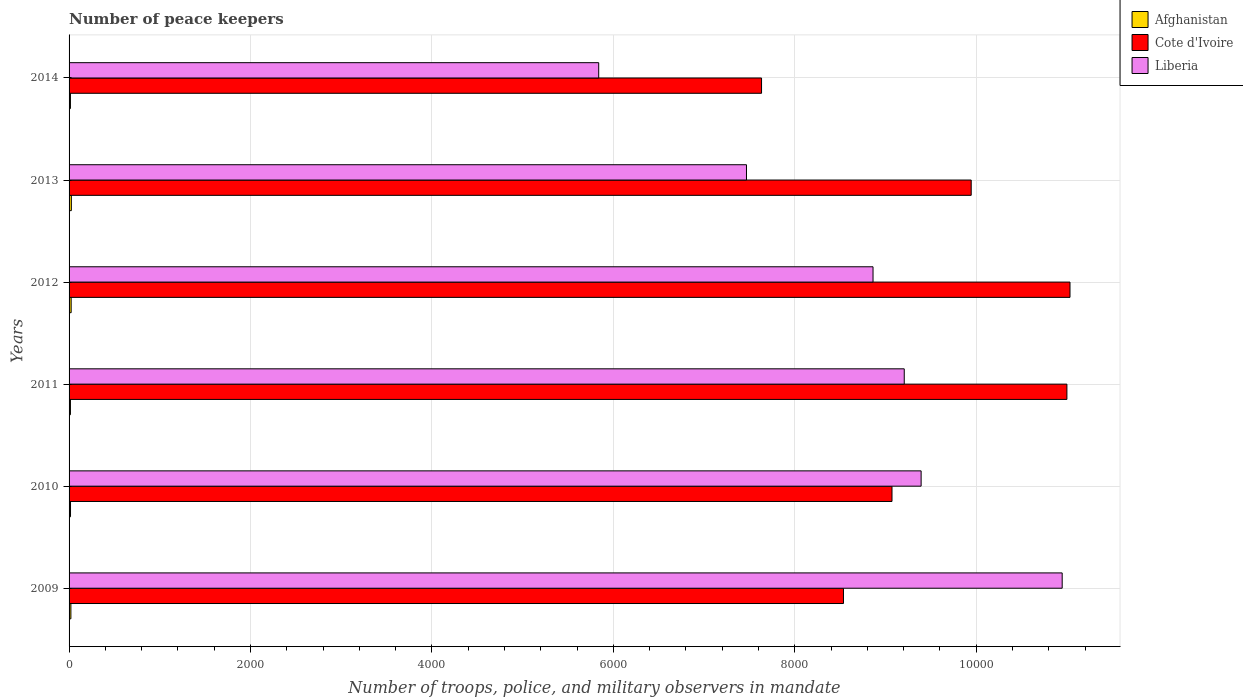How many different coloured bars are there?
Offer a terse response. 3. What is the label of the 1st group of bars from the top?
Keep it short and to the point. 2014. Across all years, what is the minimum number of peace keepers in in Afghanistan?
Make the answer very short. 15. What is the total number of peace keepers in in Afghanistan in the graph?
Keep it short and to the point. 114. What is the difference between the number of peace keepers in in Afghanistan in 2011 and the number of peace keepers in in Liberia in 2014?
Provide a succinct answer. -5823. What is the average number of peace keepers in in Afghanistan per year?
Your answer should be compact. 19. In the year 2013, what is the difference between the number of peace keepers in in Liberia and number of peace keepers in in Afghanistan?
Make the answer very short. 7442. In how many years, is the number of peace keepers in in Liberia greater than 8400 ?
Your answer should be compact. 4. What is the ratio of the number of peace keepers in in Afghanistan in 2011 to that in 2012?
Provide a short and direct response. 0.65. Is the difference between the number of peace keepers in in Liberia in 2010 and 2013 greater than the difference between the number of peace keepers in in Afghanistan in 2010 and 2013?
Provide a succinct answer. Yes. What is the difference between the highest and the second highest number of peace keepers in in Cote d'Ivoire?
Your answer should be very brief. 34. What is the difference between the highest and the lowest number of peace keepers in in Liberia?
Ensure brevity in your answer.  5109. In how many years, is the number of peace keepers in in Liberia greater than the average number of peace keepers in in Liberia taken over all years?
Your answer should be compact. 4. Is the sum of the number of peace keepers in in Cote d'Ivoire in 2010 and 2011 greater than the maximum number of peace keepers in in Afghanistan across all years?
Provide a succinct answer. Yes. What does the 3rd bar from the top in 2009 represents?
Make the answer very short. Afghanistan. What does the 1st bar from the bottom in 2011 represents?
Provide a short and direct response. Afghanistan. Is it the case that in every year, the sum of the number of peace keepers in in Cote d'Ivoire and number of peace keepers in in Liberia is greater than the number of peace keepers in in Afghanistan?
Keep it short and to the point. Yes. Are all the bars in the graph horizontal?
Your answer should be compact. Yes. How many years are there in the graph?
Provide a short and direct response. 6. Are the values on the major ticks of X-axis written in scientific E-notation?
Make the answer very short. No. How many legend labels are there?
Provide a short and direct response. 3. How are the legend labels stacked?
Offer a terse response. Vertical. What is the title of the graph?
Your response must be concise. Number of peace keepers. Does "Mozambique" appear as one of the legend labels in the graph?
Offer a terse response. No. What is the label or title of the X-axis?
Your response must be concise. Number of troops, police, and military observers in mandate. What is the label or title of the Y-axis?
Your answer should be compact. Years. What is the Number of troops, police, and military observers in mandate of Cote d'Ivoire in 2009?
Offer a terse response. 8536. What is the Number of troops, police, and military observers in mandate in Liberia in 2009?
Ensure brevity in your answer.  1.09e+04. What is the Number of troops, police, and military observers in mandate of Afghanistan in 2010?
Offer a terse response. 16. What is the Number of troops, police, and military observers in mandate in Cote d'Ivoire in 2010?
Make the answer very short. 9071. What is the Number of troops, police, and military observers in mandate in Liberia in 2010?
Ensure brevity in your answer.  9392. What is the Number of troops, police, and military observers in mandate in Afghanistan in 2011?
Keep it short and to the point. 15. What is the Number of troops, police, and military observers in mandate in Cote d'Ivoire in 2011?
Offer a very short reply. 1.10e+04. What is the Number of troops, police, and military observers in mandate of Liberia in 2011?
Your answer should be compact. 9206. What is the Number of troops, police, and military observers in mandate in Afghanistan in 2012?
Ensure brevity in your answer.  23. What is the Number of troops, police, and military observers in mandate of Cote d'Ivoire in 2012?
Keep it short and to the point. 1.10e+04. What is the Number of troops, police, and military observers in mandate of Liberia in 2012?
Your response must be concise. 8862. What is the Number of troops, police, and military observers in mandate in Cote d'Ivoire in 2013?
Ensure brevity in your answer.  9944. What is the Number of troops, police, and military observers in mandate in Liberia in 2013?
Give a very brief answer. 7467. What is the Number of troops, police, and military observers in mandate of Afghanistan in 2014?
Offer a terse response. 15. What is the Number of troops, police, and military observers in mandate of Cote d'Ivoire in 2014?
Provide a succinct answer. 7633. What is the Number of troops, police, and military observers in mandate of Liberia in 2014?
Your response must be concise. 5838. Across all years, what is the maximum Number of troops, police, and military observers in mandate of Afghanistan?
Give a very brief answer. 25. Across all years, what is the maximum Number of troops, police, and military observers in mandate in Cote d'Ivoire?
Offer a terse response. 1.10e+04. Across all years, what is the maximum Number of troops, police, and military observers in mandate of Liberia?
Ensure brevity in your answer.  1.09e+04. Across all years, what is the minimum Number of troops, police, and military observers in mandate of Afghanistan?
Make the answer very short. 15. Across all years, what is the minimum Number of troops, police, and military observers in mandate in Cote d'Ivoire?
Keep it short and to the point. 7633. Across all years, what is the minimum Number of troops, police, and military observers in mandate of Liberia?
Give a very brief answer. 5838. What is the total Number of troops, police, and military observers in mandate in Afghanistan in the graph?
Make the answer very short. 114. What is the total Number of troops, police, and military observers in mandate of Cote d'Ivoire in the graph?
Your answer should be very brief. 5.72e+04. What is the total Number of troops, police, and military observers in mandate of Liberia in the graph?
Provide a succinct answer. 5.17e+04. What is the difference between the Number of troops, police, and military observers in mandate in Afghanistan in 2009 and that in 2010?
Provide a short and direct response. 4. What is the difference between the Number of troops, police, and military observers in mandate in Cote d'Ivoire in 2009 and that in 2010?
Offer a terse response. -535. What is the difference between the Number of troops, police, and military observers in mandate in Liberia in 2009 and that in 2010?
Keep it short and to the point. 1555. What is the difference between the Number of troops, police, and military observers in mandate of Cote d'Ivoire in 2009 and that in 2011?
Keep it short and to the point. -2463. What is the difference between the Number of troops, police, and military observers in mandate of Liberia in 2009 and that in 2011?
Your answer should be very brief. 1741. What is the difference between the Number of troops, police, and military observers in mandate in Cote d'Ivoire in 2009 and that in 2012?
Provide a succinct answer. -2497. What is the difference between the Number of troops, police, and military observers in mandate in Liberia in 2009 and that in 2012?
Keep it short and to the point. 2085. What is the difference between the Number of troops, police, and military observers in mandate in Afghanistan in 2009 and that in 2013?
Offer a very short reply. -5. What is the difference between the Number of troops, police, and military observers in mandate of Cote d'Ivoire in 2009 and that in 2013?
Your answer should be compact. -1408. What is the difference between the Number of troops, police, and military observers in mandate of Liberia in 2009 and that in 2013?
Your answer should be very brief. 3480. What is the difference between the Number of troops, police, and military observers in mandate in Afghanistan in 2009 and that in 2014?
Provide a succinct answer. 5. What is the difference between the Number of troops, police, and military observers in mandate of Cote d'Ivoire in 2009 and that in 2014?
Provide a short and direct response. 903. What is the difference between the Number of troops, police, and military observers in mandate in Liberia in 2009 and that in 2014?
Offer a terse response. 5109. What is the difference between the Number of troops, police, and military observers in mandate of Cote d'Ivoire in 2010 and that in 2011?
Your answer should be compact. -1928. What is the difference between the Number of troops, police, and military observers in mandate of Liberia in 2010 and that in 2011?
Your response must be concise. 186. What is the difference between the Number of troops, police, and military observers in mandate of Cote d'Ivoire in 2010 and that in 2012?
Provide a succinct answer. -1962. What is the difference between the Number of troops, police, and military observers in mandate of Liberia in 2010 and that in 2012?
Provide a short and direct response. 530. What is the difference between the Number of troops, police, and military observers in mandate in Afghanistan in 2010 and that in 2013?
Your answer should be compact. -9. What is the difference between the Number of troops, police, and military observers in mandate of Cote d'Ivoire in 2010 and that in 2013?
Give a very brief answer. -873. What is the difference between the Number of troops, police, and military observers in mandate of Liberia in 2010 and that in 2013?
Offer a terse response. 1925. What is the difference between the Number of troops, police, and military observers in mandate in Cote d'Ivoire in 2010 and that in 2014?
Give a very brief answer. 1438. What is the difference between the Number of troops, police, and military observers in mandate in Liberia in 2010 and that in 2014?
Ensure brevity in your answer.  3554. What is the difference between the Number of troops, police, and military observers in mandate in Cote d'Ivoire in 2011 and that in 2012?
Offer a terse response. -34. What is the difference between the Number of troops, police, and military observers in mandate in Liberia in 2011 and that in 2012?
Provide a succinct answer. 344. What is the difference between the Number of troops, police, and military observers in mandate of Afghanistan in 2011 and that in 2013?
Offer a very short reply. -10. What is the difference between the Number of troops, police, and military observers in mandate in Cote d'Ivoire in 2011 and that in 2013?
Give a very brief answer. 1055. What is the difference between the Number of troops, police, and military observers in mandate of Liberia in 2011 and that in 2013?
Offer a very short reply. 1739. What is the difference between the Number of troops, police, and military observers in mandate of Afghanistan in 2011 and that in 2014?
Offer a very short reply. 0. What is the difference between the Number of troops, police, and military observers in mandate in Cote d'Ivoire in 2011 and that in 2014?
Keep it short and to the point. 3366. What is the difference between the Number of troops, police, and military observers in mandate of Liberia in 2011 and that in 2014?
Offer a terse response. 3368. What is the difference between the Number of troops, police, and military observers in mandate in Afghanistan in 2012 and that in 2013?
Keep it short and to the point. -2. What is the difference between the Number of troops, police, and military observers in mandate in Cote d'Ivoire in 2012 and that in 2013?
Make the answer very short. 1089. What is the difference between the Number of troops, police, and military observers in mandate of Liberia in 2012 and that in 2013?
Offer a terse response. 1395. What is the difference between the Number of troops, police, and military observers in mandate of Cote d'Ivoire in 2012 and that in 2014?
Your answer should be very brief. 3400. What is the difference between the Number of troops, police, and military observers in mandate in Liberia in 2012 and that in 2014?
Provide a succinct answer. 3024. What is the difference between the Number of troops, police, and military observers in mandate of Afghanistan in 2013 and that in 2014?
Your response must be concise. 10. What is the difference between the Number of troops, police, and military observers in mandate of Cote d'Ivoire in 2013 and that in 2014?
Give a very brief answer. 2311. What is the difference between the Number of troops, police, and military observers in mandate of Liberia in 2013 and that in 2014?
Ensure brevity in your answer.  1629. What is the difference between the Number of troops, police, and military observers in mandate in Afghanistan in 2009 and the Number of troops, police, and military observers in mandate in Cote d'Ivoire in 2010?
Ensure brevity in your answer.  -9051. What is the difference between the Number of troops, police, and military observers in mandate of Afghanistan in 2009 and the Number of troops, police, and military observers in mandate of Liberia in 2010?
Your response must be concise. -9372. What is the difference between the Number of troops, police, and military observers in mandate in Cote d'Ivoire in 2009 and the Number of troops, police, and military observers in mandate in Liberia in 2010?
Provide a short and direct response. -856. What is the difference between the Number of troops, police, and military observers in mandate of Afghanistan in 2009 and the Number of troops, police, and military observers in mandate of Cote d'Ivoire in 2011?
Keep it short and to the point. -1.10e+04. What is the difference between the Number of troops, police, and military observers in mandate in Afghanistan in 2009 and the Number of troops, police, and military observers in mandate in Liberia in 2011?
Offer a very short reply. -9186. What is the difference between the Number of troops, police, and military observers in mandate of Cote d'Ivoire in 2009 and the Number of troops, police, and military observers in mandate of Liberia in 2011?
Provide a succinct answer. -670. What is the difference between the Number of troops, police, and military observers in mandate of Afghanistan in 2009 and the Number of troops, police, and military observers in mandate of Cote d'Ivoire in 2012?
Provide a succinct answer. -1.10e+04. What is the difference between the Number of troops, police, and military observers in mandate of Afghanistan in 2009 and the Number of troops, police, and military observers in mandate of Liberia in 2012?
Provide a short and direct response. -8842. What is the difference between the Number of troops, police, and military observers in mandate of Cote d'Ivoire in 2009 and the Number of troops, police, and military observers in mandate of Liberia in 2012?
Offer a very short reply. -326. What is the difference between the Number of troops, police, and military observers in mandate of Afghanistan in 2009 and the Number of troops, police, and military observers in mandate of Cote d'Ivoire in 2013?
Make the answer very short. -9924. What is the difference between the Number of troops, police, and military observers in mandate of Afghanistan in 2009 and the Number of troops, police, and military observers in mandate of Liberia in 2013?
Provide a short and direct response. -7447. What is the difference between the Number of troops, police, and military observers in mandate in Cote d'Ivoire in 2009 and the Number of troops, police, and military observers in mandate in Liberia in 2013?
Offer a very short reply. 1069. What is the difference between the Number of troops, police, and military observers in mandate in Afghanistan in 2009 and the Number of troops, police, and military observers in mandate in Cote d'Ivoire in 2014?
Your answer should be very brief. -7613. What is the difference between the Number of troops, police, and military observers in mandate in Afghanistan in 2009 and the Number of troops, police, and military observers in mandate in Liberia in 2014?
Your answer should be compact. -5818. What is the difference between the Number of troops, police, and military observers in mandate in Cote d'Ivoire in 2009 and the Number of troops, police, and military observers in mandate in Liberia in 2014?
Keep it short and to the point. 2698. What is the difference between the Number of troops, police, and military observers in mandate of Afghanistan in 2010 and the Number of troops, police, and military observers in mandate of Cote d'Ivoire in 2011?
Your response must be concise. -1.10e+04. What is the difference between the Number of troops, police, and military observers in mandate in Afghanistan in 2010 and the Number of troops, police, and military observers in mandate in Liberia in 2011?
Ensure brevity in your answer.  -9190. What is the difference between the Number of troops, police, and military observers in mandate in Cote d'Ivoire in 2010 and the Number of troops, police, and military observers in mandate in Liberia in 2011?
Give a very brief answer. -135. What is the difference between the Number of troops, police, and military observers in mandate in Afghanistan in 2010 and the Number of troops, police, and military observers in mandate in Cote d'Ivoire in 2012?
Offer a very short reply. -1.10e+04. What is the difference between the Number of troops, police, and military observers in mandate of Afghanistan in 2010 and the Number of troops, police, and military observers in mandate of Liberia in 2012?
Your answer should be very brief. -8846. What is the difference between the Number of troops, police, and military observers in mandate of Cote d'Ivoire in 2010 and the Number of troops, police, and military observers in mandate of Liberia in 2012?
Your answer should be compact. 209. What is the difference between the Number of troops, police, and military observers in mandate in Afghanistan in 2010 and the Number of troops, police, and military observers in mandate in Cote d'Ivoire in 2013?
Your answer should be very brief. -9928. What is the difference between the Number of troops, police, and military observers in mandate in Afghanistan in 2010 and the Number of troops, police, and military observers in mandate in Liberia in 2013?
Keep it short and to the point. -7451. What is the difference between the Number of troops, police, and military observers in mandate of Cote d'Ivoire in 2010 and the Number of troops, police, and military observers in mandate of Liberia in 2013?
Ensure brevity in your answer.  1604. What is the difference between the Number of troops, police, and military observers in mandate of Afghanistan in 2010 and the Number of troops, police, and military observers in mandate of Cote d'Ivoire in 2014?
Provide a short and direct response. -7617. What is the difference between the Number of troops, police, and military observers in mandate of Afghanistan in 2010 and the Number of troops, police, and military observers in mandate of Liberia in 2014?
Offer a very short reply. -5822. What is the difference between the Number of troops, police, and military observers in mandate in Cote d'Ivoire in 2010 and the Number of troops, police, and military observers in mandate in Liberia in 2014?
Give a very brief answer. 3233. What is the difference between the Number of troops, police, and military observers in mandate of Afghanistan in 2011 and the Number of troops, police, and military observers in mandate of Cote d'Ivoire in 2012?
Keep it short and to the point. -1.10e+04. What is the difference between the Number of troops, police, and military observers in mandate of Afghanistan in 2011 and the Number of troops, police, and military observers in mandate of Liberia in 2012?
Provide a short and direct response. -8847. What is the difference between the Number of troops, police, and military observers in mandate in Cote d'Ivoire in 2011 and the Number of troops, police, and military observers in mandate in Liberia in 2012?
Your response must be concise. 2137. What is the difference between the Number of troops, police, and military observers in mandate in Afghanistan in 2011 and the Number of troops, police, and military observers in mandate in Cote d'Ivoire in 2013?
Your answer should be compact. -9929. What is the difference between the Number of troops, police, and military observers in mandate in Afghanistan in 2011 and the Number of troops, police, and military observers in mandate in Liberia in 2013?
Offer a very short reply. -7452. What is the difference between the Number of troops, police, and military observers in mandate in Cote d'Ivoire in 2011 and the Number of troops, police, and military observers in mandate in Liberia in 2013?
Give a very brief answer. 3532. What is the difference between the Number of troops, police, and military observers in mandate in Afghanistan in 2011 and the Number of troops, police, and military observers in mandate in Cote d'Ivoire in 2014?
Your response must be concise. -7618. What is the difference between the Number of troops, police, and military observers in mandate in Afghanistan in 2011 and the Number of troops, police, and military observers in mandate in Liberia in 2014?
Offer a very short reply. -5823. What is the difference between the Number of troops, police, and military observers in mandate in Cote d'Ivoire in 2011 and the Number of troops, police, and military observers in mandate in Liberia in 2014?
Keep it short and to the point. 5161. What is the difference between the Number of troops, police, and military observers in mandate of Afghanistan in 2012 and the Number of troops, police, and military observers in mandate of Cote d'Ivoire in 2013?
Give a very brief answer. -9921. What is the difference between the Number of troops, police, and military observers in mandate of Afghanistan in 2012 and the Number of troops, police, and military observers in mandate of Liberia in 2013?
Provide a succinct answer. -7444. What is the difference between the Number of troops, police, and military observers in mandate of Cote d'Ivoire in 2012 and the Number of troops, police, and military observers in mandate of Liberia in 2013?
Provide a succinct answer. 3566. What is the difference between the Number of troops, police, and military observers in mandate of Afghanistan in 2012 and the Number of troops, police, and military observers in mandate of Cote d'Ivoire in 2014?
Keep it short and to the point. -7610. What is the difference between the Number of troops, police, and military observers in mandate in Afghanistan in 2012 and the Number of troops, police, and military observers in mandate in Liberia in 2014?
Your response must be concise. -5815. What is the difference between the Number of troops, police, and military observers in mandate in Cote d'Ivoire in 2012 and the Number of troops, police, and military observers in mandate in Liberia in 2014?
Your answer should be very brief. 5195. What is the difference between the Number of troops, police, and military observers in mandate of Afghanistan in 2013 and the Number of troops, police, and military observers in mandate of Cote d'Ivoire in 2014?
Give a very brief answer. -7608. What is the difference between the Number of troops, police, and military observers in mandate of Afghanistan in 2013 and the Number of troops, police, and military observers in mandate of Liberia in 2014?
Make the answer very short. -5813. What is the difference between the Number of troops, police, and military observers in mandate in Cote d'Ivoire in 2013 and the Number of troops, police, and military observers in mandate in Liberia in 2014?
Offer a terse response. 4106. What is the average Number of troops, police, and military observers in mandate in Cote d'Ivoire per year?
Offer a terse response. 9536. What is the average Number of troops, police, and military observers in mandate of Liberia per year?
Give a very brief answer. 8618.67. In the year 2009, what is the difference between the Number of troops, police, and military observers in mandate of Afghanistan and Number of troops, police, and military observers in mandate of Cote d'Ivoire?
Make the answer very short. -8516. In the year 2009, what is the difference between the Number of troops, police, and military observers in mandate in Afghanistan and Number of troops, police, and military observers in mandate in Liberia?
Offer a terse response. -1.09e+04. In the year 2009, what is the difference between the Number of troops, police, and military observers in mandate in Cote d'Ivoire and Number of troops, police, and military observers in mandate in Liberia?
Make the answer very short. -2411. In the year 2010, what is the difference between the Number of troops, police, and military observers in mandate in Afghanistan and Number of troops, police, and military observers in mandate in Cote d'Ivoire?
Give a very brief answer. -9055. In the year 2010, what is the difference between the Number of troops, police, and military observers in mandate in Afghanistan and Number of troops, police, and military observers in mandate in Liberia?
Keep it short and to the point. -9376. In the year 2010, what is the difference between the Number of troops, police, and military observers in mandate in Cote d'Ivoire and Number of troops, police, and military observers in mandate in Liberia?
Your answer should be very brief. -321. In the year 2011, what is the difference between the Number of troops, police, and military observers in mandate of Afghanistan and Number of troops, police, and military observers in mandate of Cote d'Ivoire?
Ensure brevity in your answer.  -1.10e+04. In the year 2011, what is the difference between the Number of troops, police, and military observers in mandate of Afghanistan and Number of troops, police, and military observers in mandate of Liberia?
Offer a terse response. -9191. In the year 2011, what is the difference between the Number of troops, police, and military observers in mandate in Cote d'Ivoire and Number of troops, police, and military observers in mandate in Liberia?
Your answer should be compact. 1793. In the year 2012, what is the difference between the Number of troops, police, and military observers in mandate of Afghanistan and Number of troops, police, and military observers in mandate of Cote d'Ivoire?
Provide a succinct answer. -1.10e+04. In the year 2012, what is the difference between the Number of troops, police, and military observers in mandate of Afghanistan and Number of troops, police, and military observers in mandate of Liberia?
Your answer should be very brief. -8839. In the year 2012, what is the difference between the Number of troops, police, and military observers in mandate in Cote d'Ivoire and Number of troops, police, and military observers in mandate in Liberia?
Give a very brief answer. 2171. In the year 2013, what is the difference between the Number of troops, police, and military observers in mandate of Afghanistan and Number of troops, police, and military observers in mandate of Cote d'Ivoire?
Your response must be concise. -9919. In the year 2013, what is the difference between the Number of troops, police, and military observers in mandate in Afghanistan and Number of troops, police, and military observers in mandate in Liberia?
Your response must be concise. -7442. In the year 2013, what is the difference between the Number of troops, police, and military observers in mandate in Cote d'Ivoire and Number of troops, police, and military observers in mandate in Liberia?
Offer a very short reply. 2477. In the year 2014, what is the difference between the Number of troops, police, and military observers in mandate in Afghanistan and Number of troops, police, and military observers in mandate in Cote d'Ivoire?
Keep it short and to the point. -7618. In the year 2014, what is the difference between the Number of troops, police, and military observers in mandate in Afghanistan and Number of troops, police, and military observers in mandate in Liberia?
Provide a succinct answer. -5823. In the year 2014, what is the difference between the Number of troops, police, and military observers in mandate of Cote d'Ivoire and Number of troops, police, and military observers in mandate of Liberia?
Provide a succinct answer. 1795. What is the ratio of the Number of troops, police, and military observers in mandate in Afghanistan in 2009 to that in 2010?
Provide a short and direct response. 1.25. What is the ratio of the Number of troops, police, and military observers in mandate of Cote d'Ivoire in 2009 to that in 2010?
Keep it short and to the point. 0.94. What is the ratio of the Number of troops, police, and military observers in mandate in Liberia in 2009 to that in 2010?
Offer a very short reply. 1.17. What is the ratio of the Number of troops, police, and military observers in mandate in Afghanistan in 2009 to that in 2011?
Make the answer very short. 1.33. What is the ratio of the Number of troops, police, and military observers in mandate in Cote d'Ivoire in 2009 to that in 2011?
Give a very brief answer. 0.78. What is the ratio of the Number of troops, police, and military observers in mandate of Liberia in 2009 to that in 2011?
Offer a terse response. 1.19. What is the ratio of the Number of troops, police, and military observers in mandate of Afghanistan in 2009 to that in 2012?
Provide a short and direct response. 0.87. What is the ratio of the Number of troops, police, and military observers in mandate of Cote d'Ivoire in 2009 to that in 2012?
Provide a succinct answer. 0.77. What is the ratio of the Number of troops, police, and military observers in mandate in Liberia in 2009 to that in 2012?
Your answer should be very brief. 1.24. What is the ratio of the Number of troops, police, and military observers in mandate of Afghanistan in 2009 to that in 2013?
Offer a very short reply. 0.8. What is the ratio of the Number of troops, police, and military observers in mandate in Cote d'Ivoire in 2009 to that in 2013?
Ensure brevity in your answer.  0.86. What is the ratio of the Number of troops, police, and military observers in mandate of Liberia in 2009 to that in 2013?
Offer a very short reply. 1.47. What is the ratio of the Number of troops, police, and military observers in mandate of Cote d'Ivoire in 2009 to that in 2014?
Ensure brevity in your answer.  1.12. What is the ratio of the Number of troops, police, and military observers in mandate in Liberia in 2009 to that in 2014?
Offer a terse response. 1.88. What is the ratio of the Number of troops, police, and military observers in mandate of Afghanistan in 2010 to that in 2011?
Make the answer very short. 1.07. What is the ratio of the Number of troops, police, and military observers in mandate of Cote d'Ivoire in 2010 to that in 2011?
Give a very brief answer. 0.82. What is the ratio of the Number of troops, police, and military observers in mandate in Liberia in 2010 to that in 2011?
Keep it short and to the point. 1.02. What is the ratio of the Number of troops, police, and military observers in mandate of Afghanistan in 2010 to that in 2012?
Offer a very short reply. 0.7. What is the ratio of the Number of troops, police, and military observers in mandate of Cote d'Ivoire in 2010 to that in 2012?
Your response must be concise. 0.82. What is the ratio of the Number of troops, police, and military observers in mandate in Liberia in 2010 to that in 2012?
Your response must be concise. 1.06. What is the ratio of the Number of troops, police, and military observers in mandate of Afghanistan in 2010 to that in 2013?
Give a very brief answer. 0.64. What is the ratio of the Number of troops, police, and military observers in mandate of Cote d'Ivoire in 2010 to that in 2013?
Provide a succinct answer. 0.91. What is the ratio of the Number of troops, police, and military observers in mandate in Liberia in 2010 to that in 2013?
Your response must be concise. 1.26. What is the ratio of the Number of troops, police, and military observers in mandate of Afghanistan in 2010 to that in 2014?
Give a very brief answer. 1.07. What is the ratio of the Number of troops, police, and military observers in mandate of Cote d'Ivoire in 2010 to that in 2014?
Give a very brief answer. 1.19. What is the ratio of the Number of troops, police, and military observers in mandate in Liberia in 2010 to that in 2014?
Make the answer very short. 1.61. What is the ratio of the Number of troops, police, and military observers in mandate in Afghanistan in 2011 to that in 2012?
Give a very brief answer. 0.65. What is the ratio of the Number of troops, police, and military observers in mandate of Liberia in 2011 to that in 2012?
Give a very brief answer. 1.04. What is the ratio of the Number of troops, police, and military observers in mandate in Afghanistan in 2011 to that in 2013?
Offer a terse response. 0.6. What is the ratio of the Number of troops, police, and military observers in mandate of Cote d'Ivoire in 2011 to that in 2013?
Your response must be concise. 1.11. What is the ratio of the Number of troops, police, and military observers in mandate in Liberia in 2011 to that in 2013?
Provide a succinct answer. 1.23. What is the ratio of the Number of troops, police, and military observers in mandate in Afghanistan in 2011 to that in 2014?
Make the answer very short. 1. What is the ratio of the Number of troops, police, and military observers in mandate in Cote d'Ivoire in 2011 to that in 2014?
Ensure brevity in your answer.  1.44. What is the ratio of the Number of troops, police, and military observers in mandate in Liberia in 2011 to that in 2014?
Ensure brevity in your answer.  1.58. What is the ratio of the Number of troops, police, and military observers in mandate in Afghanistan in 2012 to that in 2013?
Give a very brief answer. 0.92. What is the ratio of the Number of troops, police, and military observers in mandate of Cote d'Ivoire in 2012 to that in 2013?
Give a very brief answer. 1.11. What is the ratio of the Number of troops, police, and military observers in mandate in Liberia in 2012 to that in 2013?
Give a very brief answer. 1.19. What is the ratio of the Number of troops, police, and military observers in mandate in Afghanistan in 2012 to that in 2014?
Your answer should be compact. 1.53. What is the ratio of the Number of troops, police, and military observers in mandate in Cote d'Ivoire in 2012 to that in 2014?
Make the answer very short. 1.45. What is the ratio of the Number of troops, police, and military observers in mandate of Liberia in 2012 to that in 2014?
Provide a succinct answer. 1.52. What is the ratio of the Number of troops, police, and military observers in mandate in Afghanistan in 2013 to that in 2014?
Keep it short and to the point. 1.67. What is the ratio of the Number of troops, police, and military observers in mandate of Cote d'Ivoire in 2013 to that in 2014?
Provide a short and direct response. 1.3. What is the ratio of the Number of troops, police, and military observers in mandate in Liberia in 2013 to that in 2014?
Keep it short and to the point. 1.28. What is the difference between the highest and the second highest Number of troops, police, and military observers in mandate of Afghanistan?
Your answer should be very brief. 2. What is the difference between the highest and the second highest Number of troops, police, and military observers in mandate of Liberia?
Offer a terse response. 1555. What is the difference between the highest and the lowest Number of troops, police, and military observers in mandate in Cote d'Ivoire?
Your response must be concise. 3400. What is the difference between the highest and the lowest Number of troops, police, and military observers in mandate in Liberia?
Ensure brevity in your answer.  5109. 